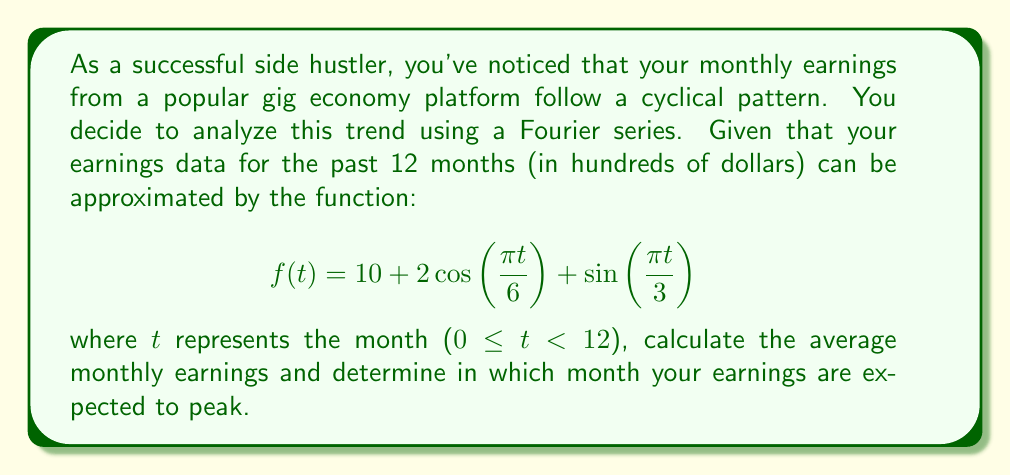Can you solve this math problem? Let's approach this step-by-step:

1) To find the average monthly earnings, we need to calculate the average value of $f(t)$ over the 12-month period. In Fourier analysis, this is given by the constant term in the series.

2) In this case, the constant term is 10, which represents $1000 in our original scale.

3) To find the peak earnings, we need to find the maximum value of $f(t)$. Let's rewrite the function in a simpler form:

   $$f(t) = 10 + 2\cos(\frac{\pi t}{6}) + \sin(\frac{\pi t}{3})$$
   
4) The maximum will occur when both cosine and sine terms are at their peak. However, they have different periods, so we need to find when their sum is maximum.

5) Let's consider the derivative of $f(t)$:

   $$f'(t) = -\frac{\pi}{3}\sin(\frac{\pi t}{6}) + \frac{\pi}{3}\cos(\frac{\pi t}{3})$$

6) Setting this to zero and solving would give us the exact peak, but it's complex. Instead, let's consider the periods:
   - $\cos(\frac{\pi t}{6})$ has a period of 12 months
   - $\sin(\frac{\pi t}{3})$ has a period of 6 months

7) The function will peak when $\cos(\frac{\pi t}{6})$ is at its maximum (1) and $\sin(\frac{\pi t}{3})$ is also at its maximum (1).

8) This occurs when $t = 0$, which corresponds to the first month in our cycle.

Therefore, earnings are expected to peak in the first month of the cycle.
Answer: Average monthly earnings: $1000; Peak earnings month: 1 